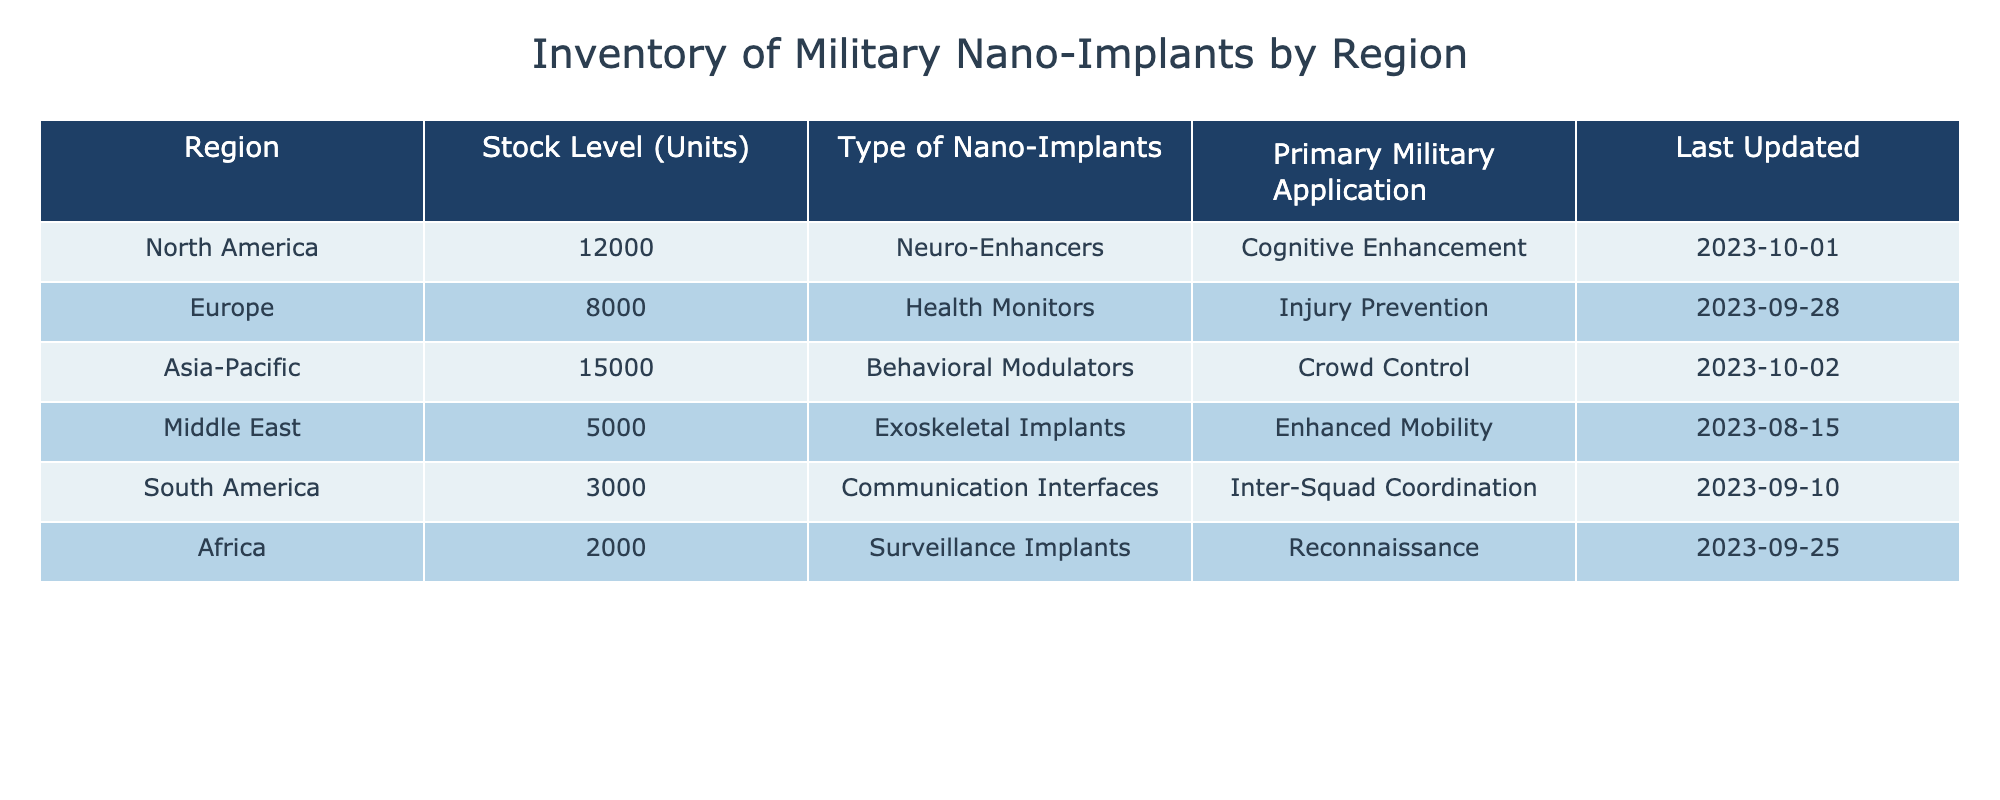What is the stock level of nano-implants in Asia-Pacific? The table shows that the stock level of nano-implants in the Asia-Pacific region is listed as 15,000 units.
Answer: 15,000 Which region has the lowest stock level of nano-implants? Looking at the stock levels in the table, Africa is shown to have the lowest stock level at 2,000 units.
Answer: Africa What type of nano-implant has the primary application of cognitive enhancement? The table indicates that "Neuro-Enhancers" are the type of nano-implant used for cognitive enhancement, specifically in the North America region.
Answer: Neuro-Enhancers Calculate the total stock level of nano-implants in North America and Europe combined. The stock level in North America is 12,000 units and in Europe is 8,000 units. Adding these together gives 12,000 + 8,000 = 20,000 units.
Answer: 20,000 Is it true that all regions have stock levels above 5,000 units? Reviewing the table, the stock levels are as follows: North America (12,000), Europe (8,000), Asia-Pacific (15,000), Middle East (5,000), South America (3,000), and Africa (2,000). Since both South America and Africa are below 5,000, the statement is false.
Answer: No Which region has more than 10,000 units of nano-implants? The table shows that the Asia-Pacific region has a stock level of 15,000 units, and North America has 12,000 units, both of which are above 10,000.
Answer: Asia-Pacific and North America What is the average stock level of nano-implants across all regions? The total stock levels are 12,000 (North America) + 8,000 (Europe) + 15,000 (Asia-Pacific) + 5,000 (Middle East) + 3,000 (South America) + 2,000 (Africa) = 45,000 units. There are six regions, so the average is 45,000 / 6 = 7,500 units.
Answer: 7,500 What is the primary military application of the nano-implants in South America? According to the table, the primary military application of the nano-implants in South America is "Inter-Squad Coordination."
Answer: Inter-Squad Coordination Is there a region that uses Health Monitors for military applications? The table notes that Health Monitors are categorized under injury prevention in the Europe region, qualifying as a military application. Therefore, the answer is yes.
Answer: Yes 